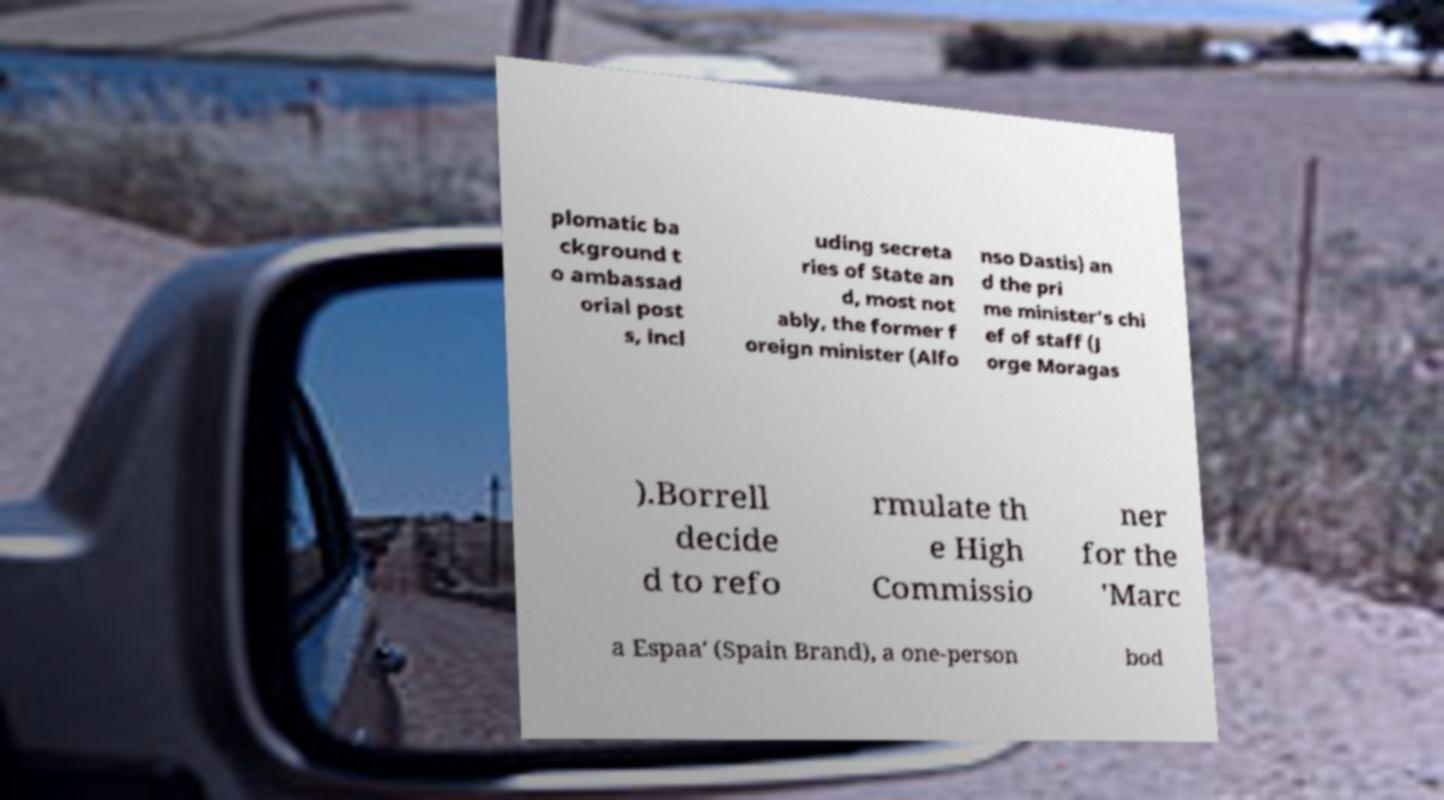Could you extract and type out the text from this image? plomatic ba ckground t o ambassad orial post s, incl uding secreta ries of State an d, most not ably, the former f oreign minister (Alfo nso Dastis) an d the pri me minister's chi ef of staff (J orge Moragas ).Borrell decide d to refo rmulate th e High Commissio ner for the 'Marc a Espaa' (Spain Brand), a one-person bod 